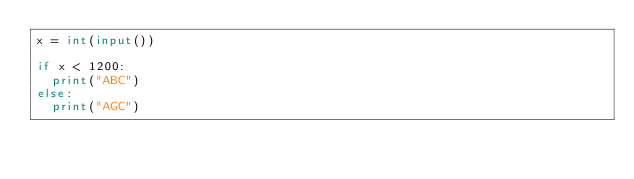<code> <loc_0><loc_0><loc_500><loc_500><_Python_>x = int(input())

if x < 1200:
  print("ABC")
else:
  print("AGC")</code> 